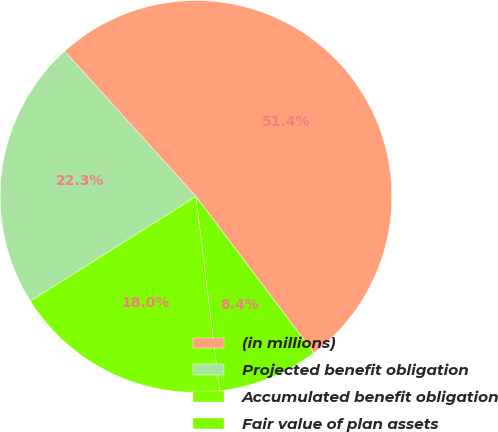Convert chart. <chart><loc_0><loc_0><loc_500><loc_500><pie_chart><fcel>(in millions)<fcel>Projected benefit obligation<fcel>Accumulated benefit obligation<fcel>Fair value of plan assets<nl><fcel>51.42%<fcel>22.27%<fcel>17.96%<fcel>8.35%<nl></chart> 